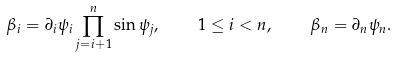<formula> <loc_0><loc_0><loc_500><loc_500>\beta _ { i } = \partial _ { i } \psi _ { i } \prod _ { j = i + 1 } ^ { n } \sin \psi _ { j } , \quad 1 \leq i < n , \quad \beta _ { n } = \partial _ { n } \psi _ { n } .</formula> 